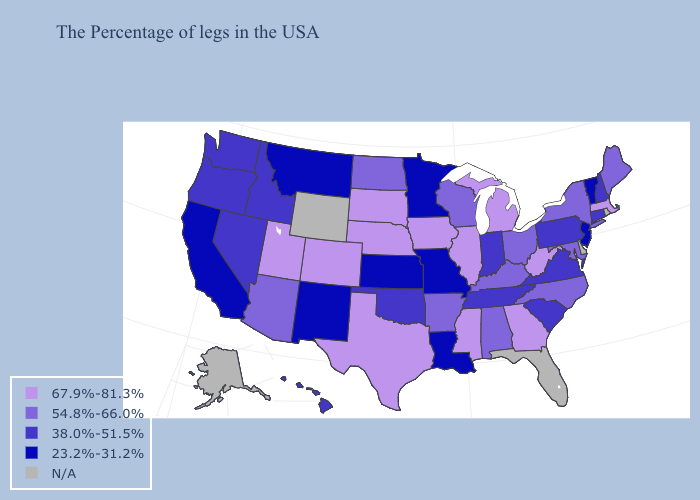What is the value of Rhode Island?
Concise answer only. N/A. Does Nebraska have the lowest value in the USA?
Give a very brief answer. No. Which states have the highest value in the USA?
Quick response, please. Massachusetts, West Virginia, Georgia, Michigan, Illinois, Mississippi, Iowa, Nebraska, Texas, South Dakota, Colorado, Utah. What is the value of Massachusetts?
Give a very brief answer. 67.9%-81.3%. What is the highest value in the USA?
Be succinct. 67.9%-81.3%. What is the value of Massachusetts?
Short answer required. 67.9%-81.3%. Name the states that have a value in the range 54.8%-66.0%?
Answer briefly. Maine, New York, Maryland, North Carolina, Ohio, Kentucky, Alabama, Wisconsin, Arkansas, North Dakota, Arizona. What is the value of Utah?
Short answer required. 67.9%-81.3%. Among the states that border South Dakota , does North Dakota have the highest value?
Short answer required. No. What is the lowest value in the USA?
Be succinct. 23.2%-31.2%. What is the highest value in states that border Maryland?
Short answer required. 67.9%-81.3%. Which states hav the highest value in the MidWest?
Keep it brief. Michigan, Illinois, Iowa, Nebraska, South Dakota. What is the value of Utah?
Answer briefly. 67.9%-81.3%. 